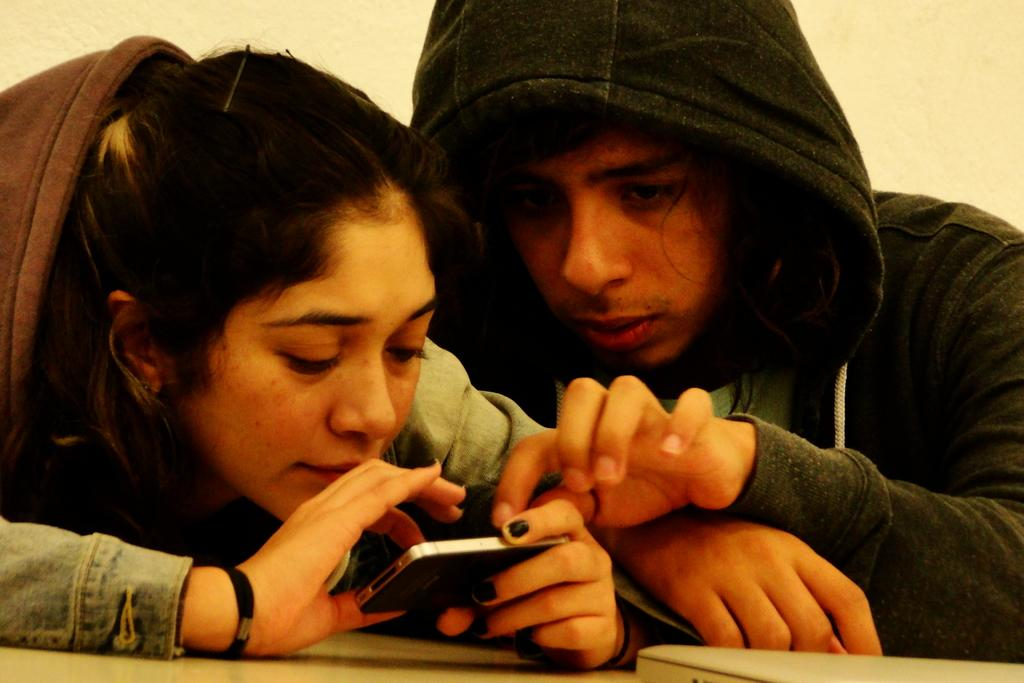How many people are in the image? There are two persons in the image. Can you describe the positions of the people in the image? There is a lady on the left side of the image and a man on the right side of the image. What is the lady holding in the image? The lady is holding a phone. What electronic device can be seen on the table in the image? There is a laptop on the table in the image. What type of corn is being served on the table in the image? There is no corn present in the image; it only features a laptop on the table. How quiet is the environment in the image? The image does not provide any information about the noise level or the environment's quietness. 